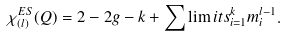<formula> <loc_0><loc_0><loc_500><loc_500>\chi _ { ( l ) } ^ { E S } ( Q ) = 2 - 2 g - k + \sum \lim i t s _ { i = 1 } ^ { k } m _ { i } ^ { l - 1 } .</formula> 